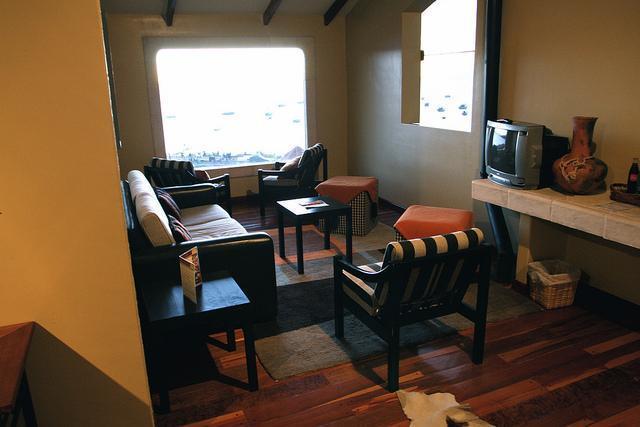How many chairs are there?
Give a very brief answer. 2. How many couches are there?
Give a very brief answer. 1. How many tvs can be seen?
Give a very brief answer. 2. How many people in the photo?
Give a very brief answer. 0. 